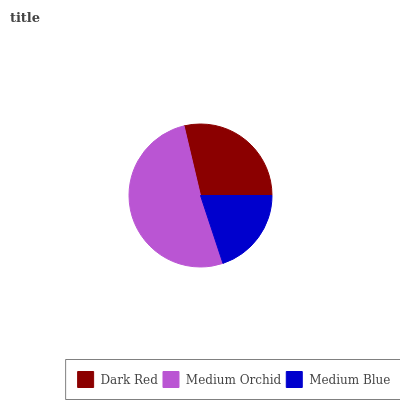Is Medium Blue the minimum?
Answer yes or no. Yes. Is Medium Orchid the maximum?
Answer yes or no. Yes. Is Medium Orchid the minimum?
Answer yes or no. No. Is Medium Blue the maximum?
Answer yes or no. No. Is Medium Orchid greater than Medium Blue?
Answer yes or no. Yes. Is Medium Blue less than Medium Orchid?
Answer yes or no. Yes. Is Medium Blue greater than Medium Orchid?
Answer yes or no. No. Is Medium Orchid less than Medium Blue?
Answer yes or no. No. Is Dark Red the high median?
Answer yes or no. Yes. Is Dark Red the low median?
Answer yes or no. Yes. Is Medium Blue the high median?
Answer yes or no. No. Is Medium Blue the low median?
Answer yes or no. No. 